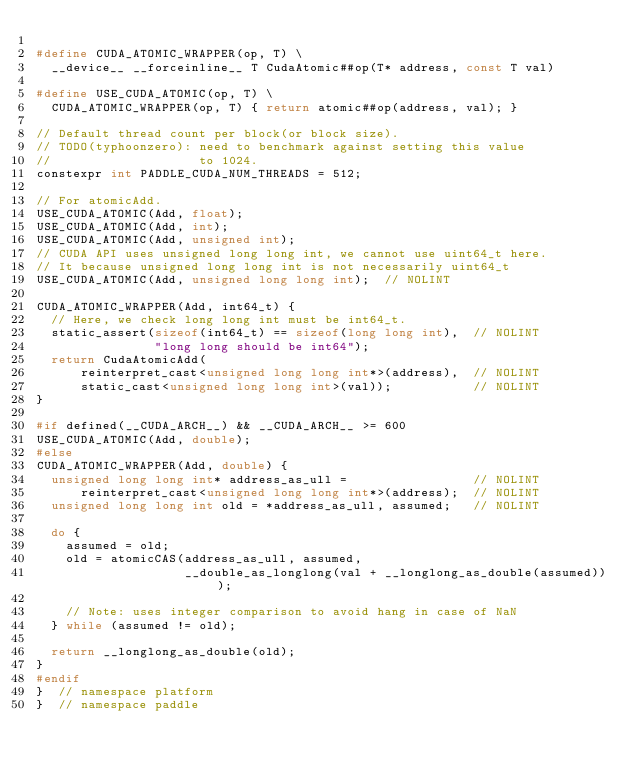<code> <loc_0><loc_0><loc_500><loc_500><_C_>
#define CUDA_ATOMIC_WRAPPER(op, T) \
  __device__ __forceinline__ T CudaAtomic##op(T* address, const T val)

#define USE_CUDA_ATOMIC(op, T) \
  CUDA_ATOMIC_WRAPPER(op, T) { return atomic##op(address, val); }

// Default thread count per block(or block size).
// TODO(typhoonzero): need to benchmark against setting this value
//                    to 1024.
constexpr int PADDLE_CUDA_NUM_THREADS = 512;

// For atomicAdd.
USE_CUDA_ATOMIC(Add, float);
USE_CUDA_ATOMIC(Add, int);
USE_CUDA_ATOMIC(Add, unsigned int);
// CUDA API uses unsigned long long int, we cannot use uint64_t here.
// It because unsigned long long int is not necessarily uint64_t
USE_CUDA_ATOMIC(Add, unsigned long long int);  // NOLINT

CUDA_ATOMIC_WRAPPER(Add, int64_t) {
  // Here, we check long long int must be int64_t.
  static_assert(sizeof(int64_t) == sizeof(long long int),  // NOLINT
                "long long should be int64");
  return CudaAtomicAdd(
      reinterpret_cast<unsigned long long int*>(address),  // NOLINT
      static_cast<unsigned long long int>(val));           // NOLINT
}

#if defined(__CUDA_ARCH__) && __CUDA_ARCH__ >= 600
USE_CUDA_ATOMIC(Add, double);
#else
CUDA_ATOMIC_WRAPPER(Add, double) {
  unsigned long long int* address_as_ull =                 // NOLINT
      reinterpret_cast<unsigned long long int*>(address);  // NOLINT
  unsigned long long int old = *address_as_ull, assumed;   // NOLINT

  do {
    assumed = old;
    old = atomicCAS(address_as_ull, assumed,
                    __double_as_longlong(val + __longlong_as_double(assumed)));

    // Note: uses integer comparison to avoid hang in case of NaN
  } while (assumed != old);

  return __longlong_as_double(old);
}
#endif
}  // namespace platform
}  // namespace paddle
</code> 